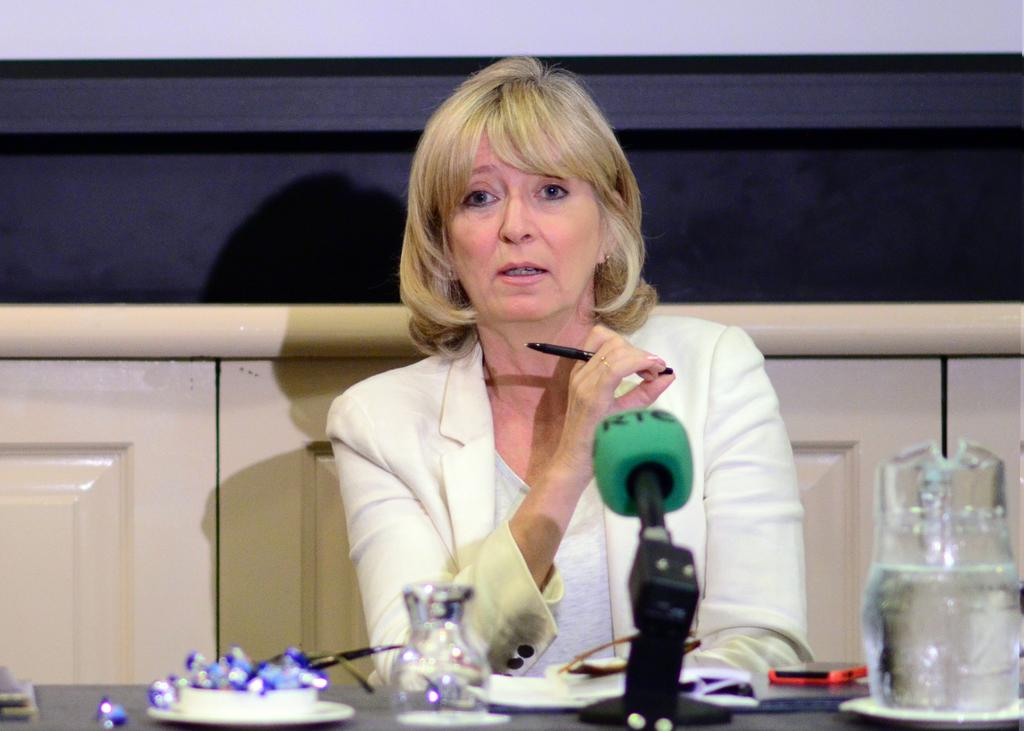<image>
Offer a succinct explanation of the picture presented. A woman sits in front of a blue padded RTC microphone. 